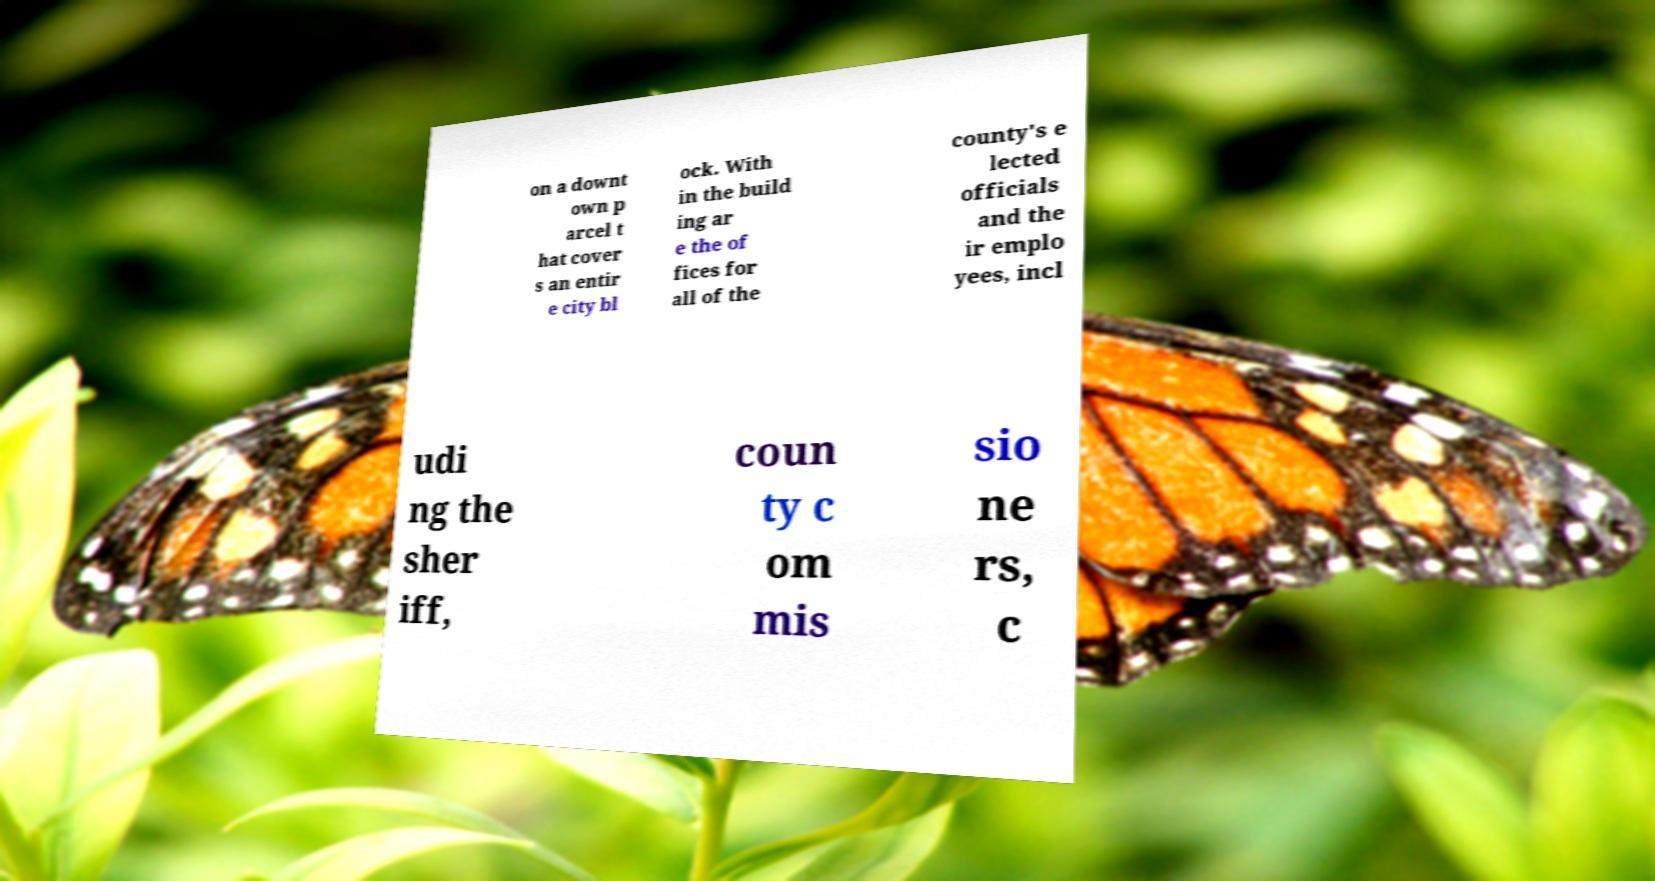Please read and relay the text visible in this image. What does it say? on a downt own p arcel t hat cover s an entir e city bl ock. With in the build ing ar e the of fices for all of the county's e lected officials and the ir emplo yees, incl udi ng the sher iff, coun ty c om mis sio ne rs, c 